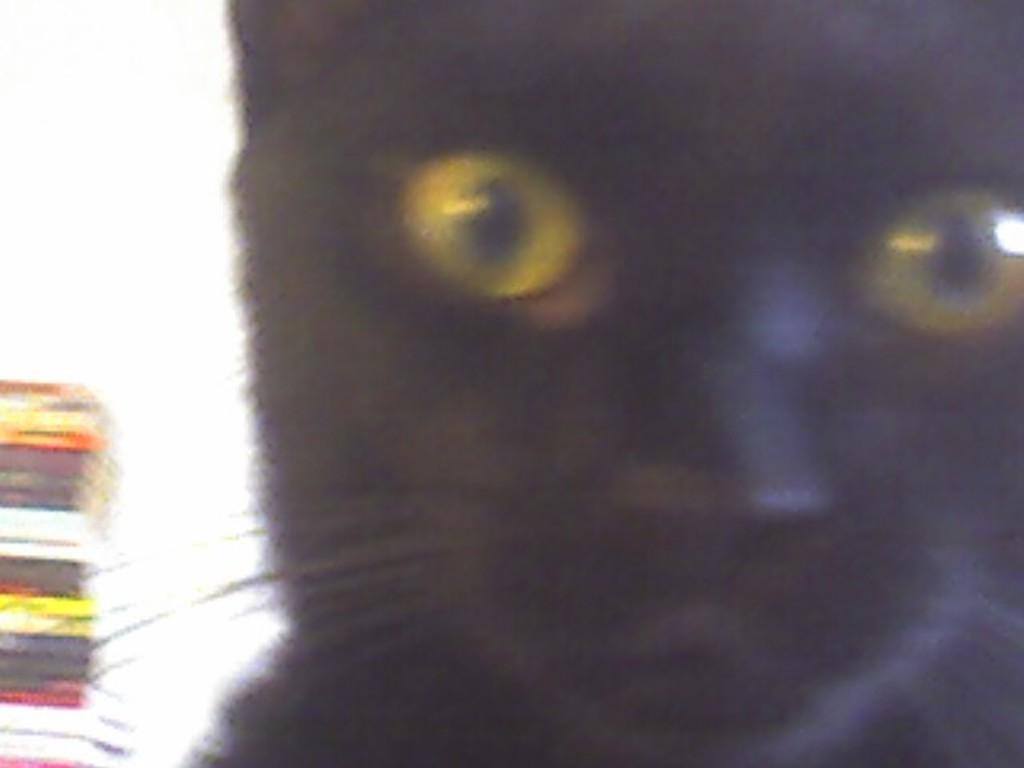What type of animal is in the image? There is a black colored cat in the image. What can be observed about the cat's eyes? The cat's eyes are yellow and black in color. What objects are visible on the left side of the image? There are books visible on the left side of the image. What is the color of the background in the image? The background of the image is white in color. Can you tell me how many turkeys are present in the image? There are no turkeys present in the image; it features a black colored cat with yellow and black eyes, books on the left side, and a white background. 